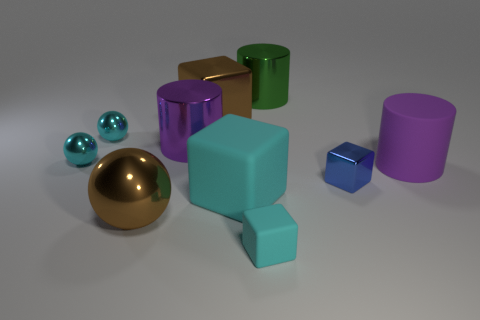Subtract all cyan blocks. How many were subtracted if there are1cyan blocks left? 1 Subtract all tiny blue metallic cubes. How many cubes are left? 3 Subtract all brown balls. How many balls are left? 2 Subtract all cylinders. How many objects are left? 7 Subtract 3 cubes. How many cubes are left? 1 Subtract all yellow cubes. How many green cylinders are left? 1 Subtract all red spheres. Subtract all purple objects. How many objects are left? 8 Add 2 cylinders. How many cylinders are left? 5 Add 10 small purple things. How many small purple things exist? 10 Subtract 1 cyan blocks. How many objects are left? 9 